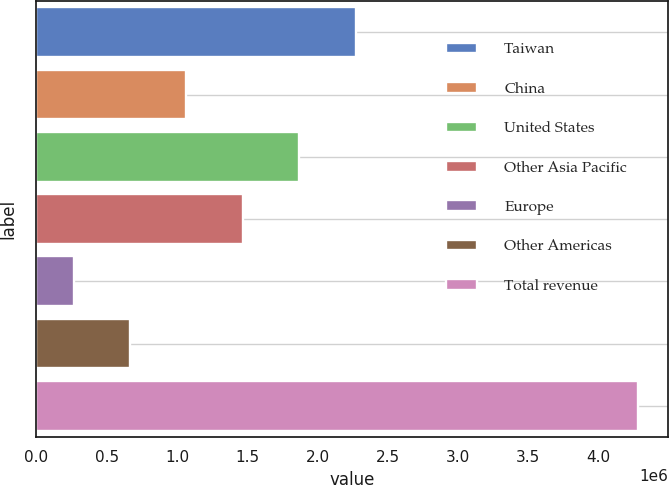Convert chart to OTSL. <chart><loc_0><loc_0><loc_500><loc_500><bar_chart><fcel>Taiwan<fcel>China<fcel>United States<fcel>Other Asia Pacific<fcel>Europe<fcel>Other Americas<fcel>Total revenue<nl><fcel>2.27182e+06<fcel>1.06682e+06<fcel>1.87016e+06<fcel>1.46849e+06<fcel>263488<fcel>665155<fcel>4.28016e+06<nl></chart> 